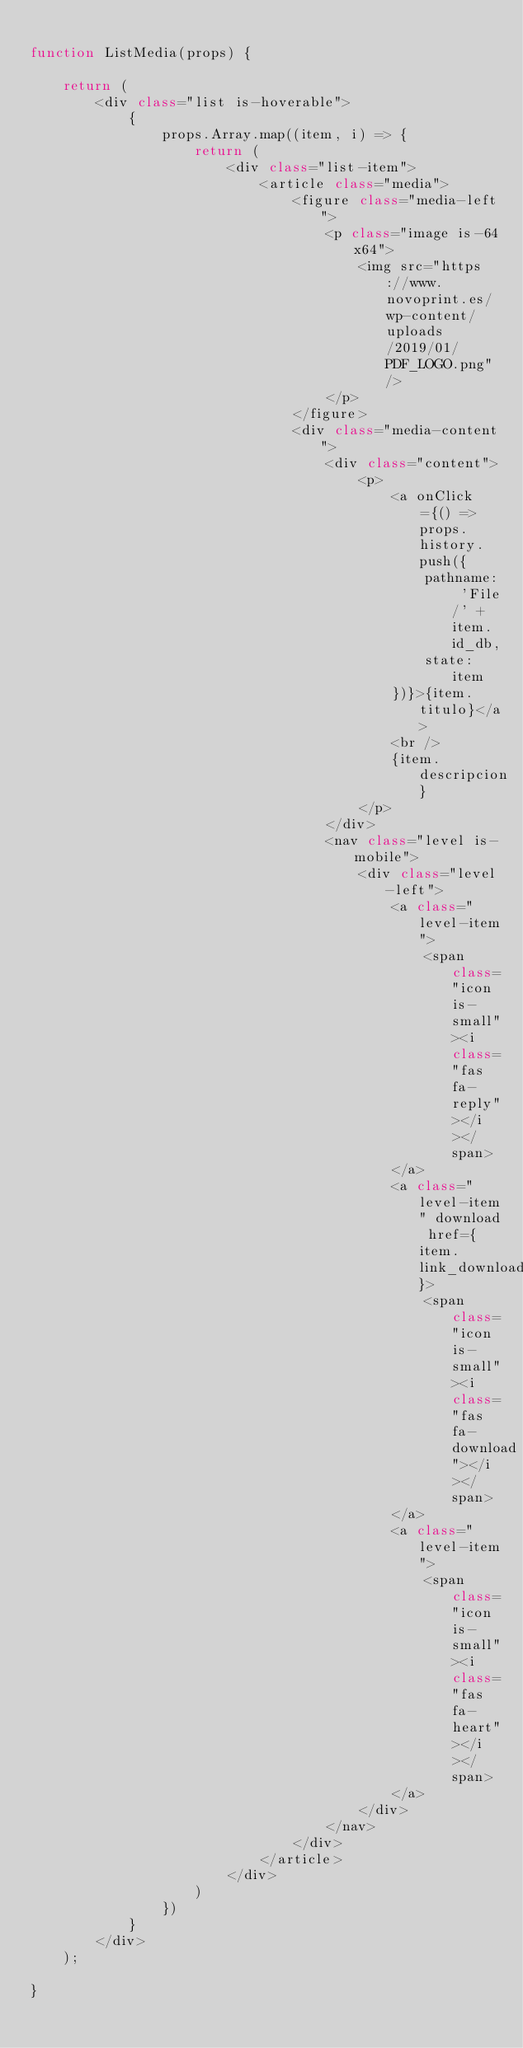Convert code to text. <code><loc_0><loc_0><loc_500><loc_500><_JavaScript_>
function ListMedia(props) {

    return (
        <div class="list is-hoverable">
            {
                props.Array.map((item, i) => {
                    return (
                        <div class="list-item">
                            <article class="media">
                                <figure class="media-left">
                                    <p class="image is-64x64">
                                        <img src="https://www.novoprint.es/wp-content/uploads/2019/01/PDF_LOGO.png" />
                                    </p>
                                </figure>
                                <div class="media-content">
                                    <div class="content">
                                        <p>
                                            <a onClick={() => props.history.push({
                                                pathname: 'File/' + item.id_db,
                                                state: item
                                            })}>{item.titulo}</a>
                                            <br />
                                            {item.descripcion}
                                        </p>
                                    </div>
                                    <nav class="level is-mobile">
                                        <div class="level-left">
                                            <a class="level-item">
                                                <span class="icon is-small"><i class="fas fa-reply"></i></span>
                                            </a>
                                            <a class="level-item" download href={item.link_download}>
                                                <span class="icon is-small"><i class="fas fa-download"></i></span>
                                            </a>
                                            <a class="level-item">
                                                <span class="icon is-small"><i class="fas fa-heart"></i></span>
                                            </a>
                                        </div>
                                    </nav>
                                </div>
                            </article>
                        </div>
                    )
                })
            }
        </div>
    );

}</code> 